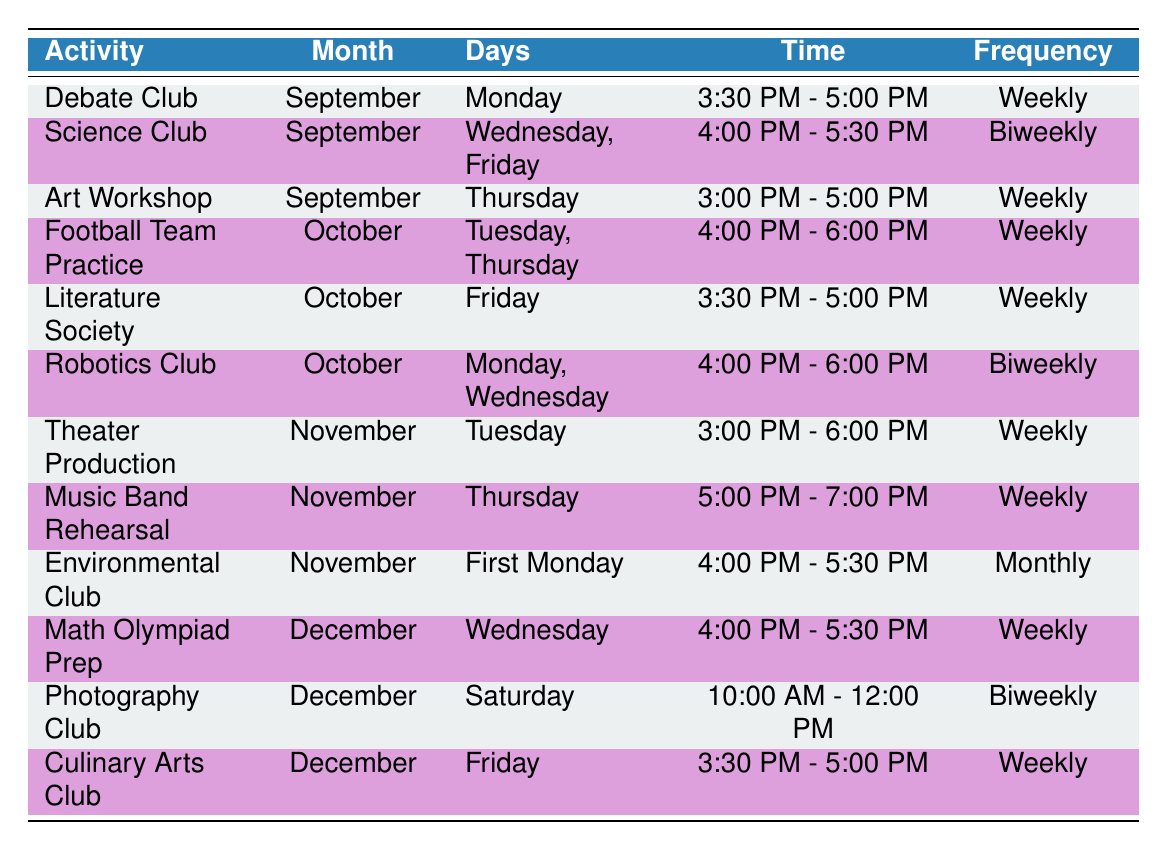What extracurricular activity meets weekly on Fridays in October? From the table, I can see that the "Literature Society" is the only activity in October that meets weekly on Friday.
Answer: Literature Society How many extracurricular activities are there in September? By counting the rows in the September section of the table, I find there are 3 activities: Debate Club, Science Club, and Art Workshop.
Answer: 3 Is the Environmental Club a weekly activity? The Environmental Club is listed with a frequency of "Monthly," which means it does not occur weekly.
Answer: No What is the earliest time for an activity in November? The activities in November start at 3:00 PM (Theater Production) and the next one is at 5:00 PM (Music Band Rehearsal), making 3:00 PM the earliest.
Answer: 3:00 PM How many days does the Robotics Club meet in October? The Robotics Club is scheduled for Monday and Wednesday, totaling 2 days.
Answer: 2 Which two activities in December have a frequency of "Weekly"? From the data, "Math Olympiad Prep" and "Culinary Arts Club" both occur weekly in December.
Answer: Math Olympiad Prep, Culinary Arts Club How many activities occur biweekly in October? There is one biweekly activity in October, which is the "Robotics Club."
Answer: 1 Which month has the most activities listed, and how many are there? In the data, there are 3 activities in September, 3 in October, 3 in November, and 3 in December, making all months equal with 3 activities.
Answer: September, October, November, December - 3 activities each What is the difference in the number of days of the week that the Debate Club and the Football Team Practice meet? The Debate Club meets on 1 day (Monday), while the Football Team Practice meets on 2 days (Tuesday, Thursday). The difference is 1 day.
Answer: 1 day 